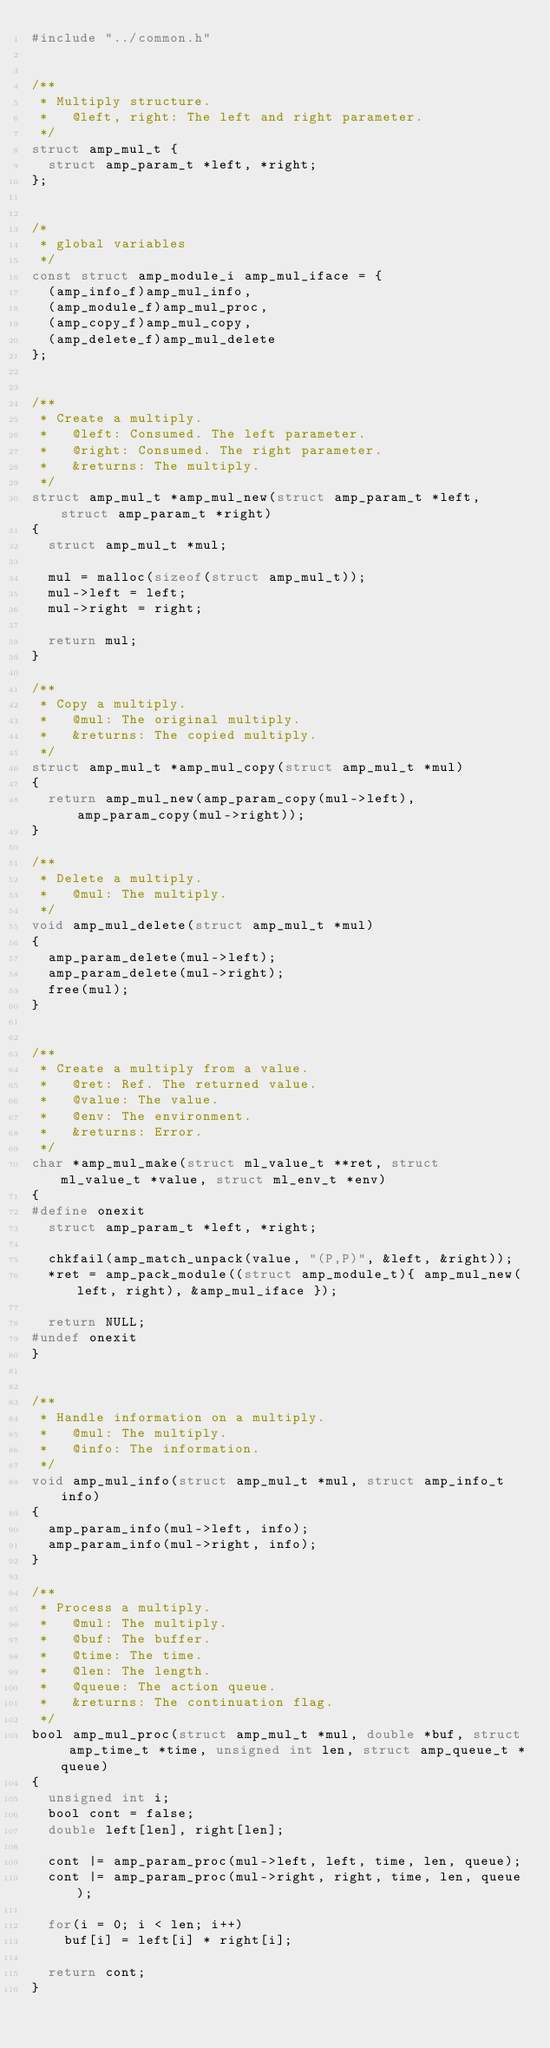<code> <loc_0><loc_0><loc_500><loc_500><_C_>#include "../common.h"


/**
 * Multiply structure.
 *   @left, right: The left and right parameter.
 */
struct amp_mul_t {
	struct amp_param_t *left, *right;
};


/*
 * global variables
 */
const struct amp_module_i amp_mul_iface = {
	(amp_info_f)amp_mul_info,
	(amp_module_f)amp_mul_proc,
	(amp_copy_f)amp_mul_copy,
	(amp_delete_f)amp_mul_delete
};


/**
 * Create a multiply.
 *   @left: Consumed. The left parameter.
 *   @right: Consumed. The right parameter.
 *   &returns: The multiply.
 */
struct amp_mul_t *amp_mul_new(struct amp_param_t *left, struct amp_param_t *right)
{
	struct amp_mul_t *mul;

	mul = malloc(sizeof(struct amp_mul_t));
	mul->left = left;
	mul->right = right;

	return mul;
}

/**
 * Copy a multiply.
 *   @mul: The original multiply.
 *   &returns: The copied multiply.
 */
struct amp_mul_t *amp_mul_copy(struct amp_mul_t *mul)
{
	return amp_mul_new(amp_param_copy(mul->left), amp_param_copy(mul->right));
}

/**
 * Delete a multiply.
 *   @mul: The multiply.
 */
void amp_mul_delete(struct amp_mul_t *mul)
{
	amp_param_delete(mul->left);
	amp_param_delete(mul->right);
	free(mul);
}


/**
 * Create a multiply from a value.
 *   @ret: Ref. The returned value.
 *   @value: The value.
 *   @env: The environment.
 *   &returns: Error.
 */
char *amp_mul_make(struct ml_value_t **ret, struct ml_value_t *value, struct ml_env_t *env)
{
#define onexit
	struct amp_param_t *left, *right;

	chkfail(amp_match_unpack(value, "(P,P)", &left, &right));
	*ret = amp_pack_module((struct amp_module_t){ amp_mul_new(left, right), &amp_mul_iface });

	return NULL;
#undef onexit
}


/**
 * Handle information on a multiply.
 *   @mul: The multiply.
 *   @info: The information.
 */
void amp_mul_info(struct amp_mul_t *mul, struct amp_info_t info)
{
	amp_param_info(mul->left, info);
	amp_param_info(mul->right, info);
}

/**
 * Process a multiply.
 *   @mul: The multiply.
 *   @buf: The buffer.
 *   @time: The time.
 *   @len: The length.
 *   @queue: The action queue.
 *   &returns: The continuation flag.
 */
bool amp_mul_proc(struct amp_mul_t *mul, double *buf, struct amp_time_t *time, unsigned int len, struct amp_queue_t *queue)
{
	unsigned int i;
	bool cont = false;
	double left[len], right[len];

	cont |= amp_param_proc(mul->left, left, time, len, queue);
	cont |= amp_param_proc(mul->right, right, time, len, queue);

	for(i = 0; i < len; i++)
		buf[i] = left[i] * right[i];

	return cont;
}
</code> 